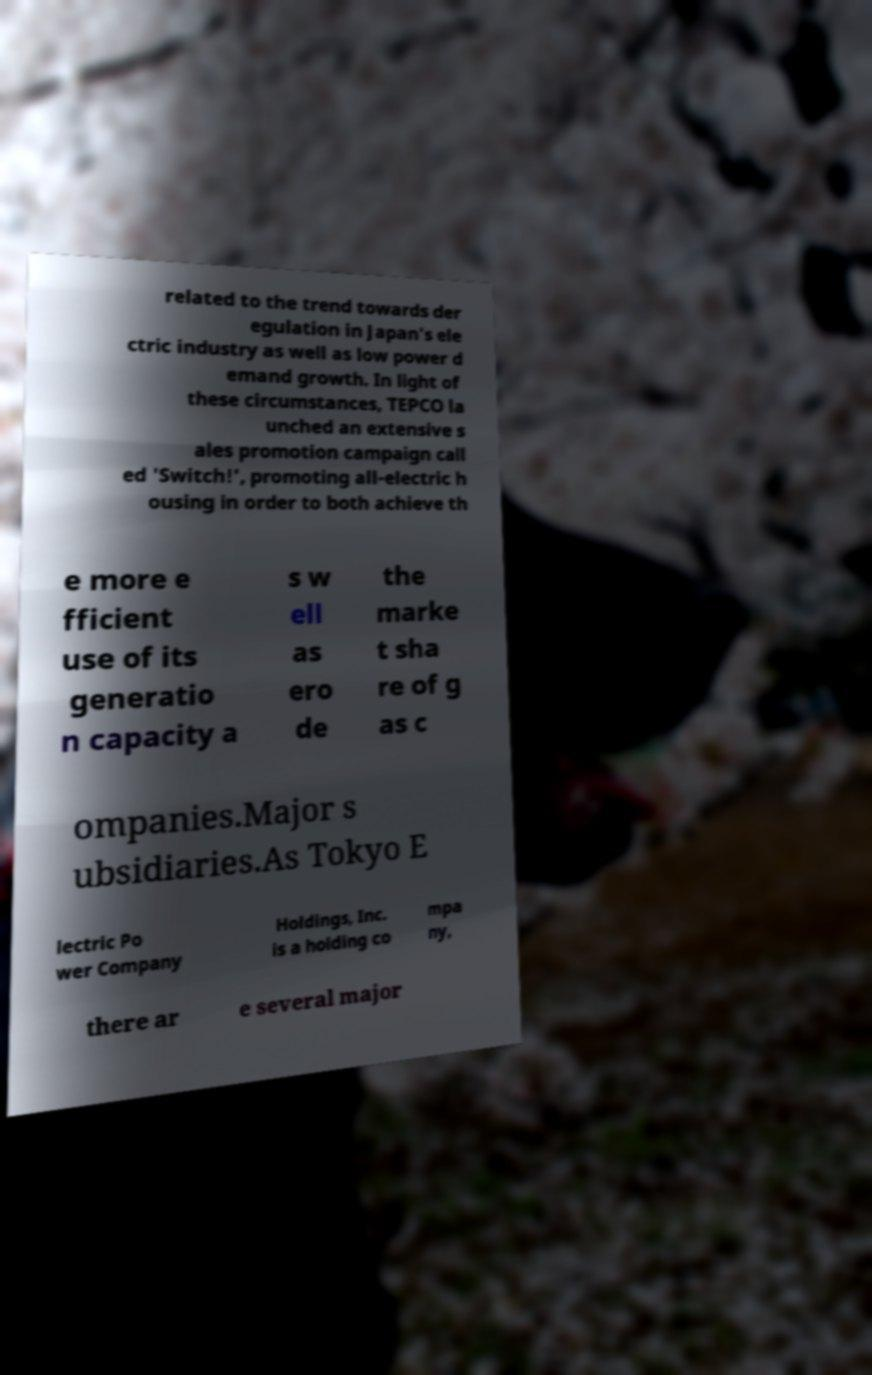There's text embedded in this image that I need extracted. Can you transcribe it verbatim? related to the trend towards der egulation in Japan's ele ctric industry as well as low power d emand growth. In light of these circumstances, TEPCO la unched an extensive s ales promotion campaign call ed 'Switch!', promoting all-electric h ousing in order to both achieve th e more e fficient use of its generatio n capacity a s w ell as ero de the marke t sha re of g as c ompanies.Major s ubsidiaries.As Tokyo E lectric Po wer Company Holdings, Inc. is a holding co mpa ny, there ar e several major 